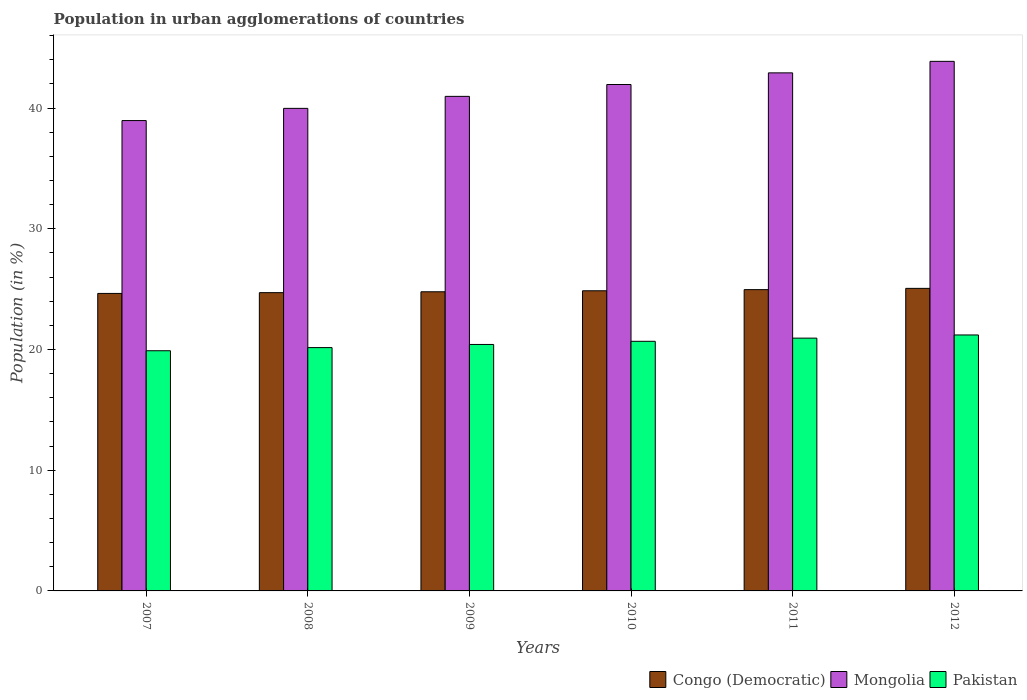How many groups of bars are there?
Give a very brief answer. 6. How many bars are there on the 6th tick from the left?
Your response must be concise. 3. How many bars are there on the 5th tick from the right?
Give a very brief answer. 3. What is the label of the 5th group of bars from the left?
Provide a succinct answer. 2011. What is the percentage of population in urban agglomerations in Mongolia in 2009?
Offer a terse response. 40.96. Across all years, what is the maximum percentage of population in urban agglomerations in Mongolia?
Your response must be concise. 43.86. Across all years, what is the minimum percentage of population in urban agglomerations in Pakistan?
Keep it short and to the point. 19.89. In which year was the percentage of population in urban agglomerations in Mongolia minimum?
Provide a succinct answer. 2007. What is the total percentage of population in urban agglomerations in Pakistan in the graph?
Offer a terse response. 123.28. What is the difference between the percentage of population in urban agglomerations in Congo (Democratic) in 2008 and that in 2009?
Your response must be concise. -0.07. What is the difference between the percentage of population in urban agglomerations in Congo (Democratic) in 2011 and the percentage of population in urban agglomerations in Mongolia in 2010?
Your response must be concise. -16.99. What is the average percentage of population in urban agglomerations in Mongolia per year?
Provide a short and direct response. 41.44. In the year 2009, what is the difference between the percentage of population in urban agglomerations in Mongolia and percentage of population in urban agglomerations in Pakistan?
Ensure brevity in your answer.  20.55. In how many years, is the percentage of population in urban agglomerations in Mongolia greater than 36 %?
Offer a very short reply. 6. What is the ratio of the percentage of population in urban agglomerations in Mongolia in 2008 to that in 2012?
Make the answer very short. 0.91. Is the percentage of population in urban agglomerations in Congo (Democratic) in 2011 less than that in 2012?
Provide a succinct answer. Yes. What is the difference between the highest and the second highest percentage of population in urban agglomerations in Mongolia?
Offer a very short reply. 0.95. What is the difference between the highest and the lowest percentage of population in urban agglomerations in Mongolia?
Provide a succinct answer. 4.91. Is the sum of the percentage of population in urban agglomerations in Congo (Democratic) in 2008 and 2009 greater than the maximum percentage of population in urban agglomerations in Pakistan across all years?
Offer a terse response. Yes. What does the 3rd bar from the left in 2007 represents?
Give a very brief answer. Pakistan. What does the 2nd bar from the right in 2010 represents?
Provide a short and direct response. Mongolia. Are all the bars in the graph horizontal?
Your answer should be very brief. No. How many years are there in the graph?
Provide a short and direct response. 6. What is the difference between two consecutive major ticks on the Y-axis?
Your answer should be very brief. 10. Are the values on the major ticks of Y-axis written in scientific E-notation?
Ensure brevity in your answer.  No. Where does the legend appear in the graph?
Offer a very short reply. Bottom right. How many legend labels are there?
Ensure brevity in your answer.  3. What is the title of the graph?
Provide a short and direct response. Population in urban agglomerations of countries. What is the label or title of the X-axis?
Your answer should be compact. Years. What is the label or title of the Y-axis?
Provide a succinct answer. Population (in %). What is the Population (in %) of Congo (Democratic) in 2007?
Provide a succinct answer. 24.64. What is the Population (in %) in Mongolia in 2007?
Your answer should be very brief. 38.96. What is the Population (in %) of Pakistan in 2007?
Give a very brief answer. 19.89. What is the Population (in %) in Congo (Democratic) in 2008?
Offer a terse response. 24.71. What is the Population (in %) of Mongolia in 2008?
Make the answer very short. 39.97. What is the Population (in %) in Pakistan in 2008?
Give a very brief answer. 20.15. What is the Population (in %) of Congo (Democratic) in 2009?
Provide a short and direct response. 24.78. What is the Population (in %) in Mongolia in 2009?
Your answer should be very brief. 40.96. What is the Population (in %) in Pakistan in 2009?
Your answer should be compact. 20.41. What is the Population (in %) of Congo (Democratic) in 2010?
Offer a terse response. 24.86. What is the Population (in %) of Mongolia in 2010?
Your answer should be very brief. 41.95. What is the Population (in %) of Pakistan in 2010?
Offer a terse response. 20.68. What is the Population (in %) in Congo (Democratic) in 2011?
Your answer should be compact. 24.96. What is the Population (in %) of Mongolia in 2011?
Your answer should be compact. 42.91. What is the Population (in %) in Pakistan in 2011?
Provide a short and direct response. 20.94. What is the Population (in %) of Congo (Democratic) in 2012?
Your answer should be very brief. 25.06. What is the Population (in %) of Mongolia in 2012?
Provide a succinct answer. 43.86. What is the Population (in %) of Pakistan in 2012?
Make the answer very short. 21.2. Across all years, what is the maximum Population (in %) in Congo (Democratic)?
Provide a succinct answer. 25.06. Across all years, what is the maximum Population (in %) in Mongolia?
Your response must be concise. 43.86. Across all years, what is the maximum Population (in %) of Pakistan?
Offer a very short reply. 21.2. Across all years, what is the minimum Population (in %) of Congo (Democratic)?
Provide a short and direct response. 24.64. Across all years, what is the minimum Population (in %) in Mongolia?
Give a very brief answer. 38.96. Across all years, what is the minimum Population (in %) in Pakistan?
Your response must be concise. 19.89. What is the total Population (in %) in Congo (Democratic) in the graph?
Ensure brevity in your answer.  149. What is the total Population (in %) in Mongolia in the graph?
Provide a short and direct response. 248.61. What is the total Population (in %) of Pakistan in the graph?
Give a very brief answer. 123.28. What is the difference between the Population (in %) of Congo (Democratic) in 2007 and that in 2008?
Provide a succinct answer. -0.07. What is the difference between the Population (in %) in Mongolia in 2007 and that in 2008?
Keep it short and to the point. -1.01. What is the difference between the Population (in %) of Pakistan in 2007 and that in 2008?
Provide a short and direct response. -0.26. What is the difference between the Population (in %) of Congo (Democratic) in 2007 and that in 2009?
Ensure brevity in your answer.  -0.14. What is the difference between the Population (in %) in Mongolia in 2007 and that in 2009?
Offer a very short reply. -2.01. What is the difference between the Population (in %) of Pakistan in 2007 and that in 2009?
Offer a terse response. -0.52. What is the difference between the Population (in %) in Congo (Democratic) in 2007 and that in 2010?
Make the answer very short. -0.22. What is the difference between the Population (in %) of Mongolia in 2007 and that in 2010?
Your answer should be compact. -2.99. What is the difference between the Population (in %) of Pakistan in 2007 and that in 2010?
Keep it short and to the point. -0.78. What is the difference between the Population (in %) of Congo (Democratic) in 2007 and that in 2011?
Offer a terse response. -0.31. What is the difference between the Population (in %) in Mongolia in 2007 and that in 2011?
Give a very brief answer. -3.95. What is the difference between the Population (in %) in Pakistan in 2007 and that in 2011?
Keep it short and to the point. -1.04. What is the difference between the Population (in %) in Congo (Democratic) in 2007 and that in 2012?
Make the answer very short. -0.42. What is the difference between the Population (in %) of Mongolia in 2007 and that in 2012?
Ensure brevity in your answer.  -4.91. What is the difference between the Population (in %) of Pakistan in 2007 and that in 2012?
Make the answer very short. -1.31. What is the difference between the Population (in %) in Congo (Democratic) in 2008 and that in 2009?
Ensure brevity in your answer.  -0.07. What is the difference between the Population (in %) in Mongolia in 2008 and that in 2009?
Make the answer very short. -0.99. What is the difference between the Population (in %) of Pakistan in 2008 and that in 2009?
Your response must be concise. -0.26. What is the difference between the Population (in %) of Congo (Democratic) in 2008 and that in 2010?
Your answer should be very brief. -0.16. What is the difference between the Population (in %) in Mongolia in 2008 and that in 2010?
Your response must be concise. -1.98. What is the difference between the Population (in %) of Pakistan in 2008 and that in 2010?
Your answer should be very brief. -0.52. What is the difference between the Population (in %) in Congo (Democratic) in 2008 and that in 2011?
Give a very brief answer. -0.25. What is the difference between the Population (in %) in Mongolia in 2008 and that in 2011?
Your answer should be very brief. -2.94. What is the difference between the Population (in %) of Pakistan in 2008 and that in 2011?
Provide a succinct answer. -0.78. What is the difference between the Population (in %) in Congo (Democratic) in 2008 and that in 2012?
Your response must be concise. -0.35. What is the difference between the Population (in %) in Mongolia in 2008 and that in 2012?
Provide a short and direct response. -3.89. What is the difference between the Population (in %) of Pakistan in 2008 and that in 2012?
Your answer should be very brief. -1.05. What is the difference between the Population (in %) of Congo (Democratic) in 2009 and that in 2010?
Provide a short and direct response. -0.08. What is the difference between the Population (in %) in Mongolia in 2009 and that in 2010?
Offer a very short reply. -0.98. What is the difference between the Population (in %) of Pakistan in 2009 and that in 2010?
Provide a short and direct response. -0.26. What is the difference between the Population (in %) of Congo (Democratic) in 2009 and that in 2011?
Keep it short and to the point. -0.18. What is the difference between the Population (in %) in Mongolia in 2009 and that in 2011?
Provide a succinct answer. -1.95. What is the difference between the Population (in %) in Pakistan in 2009 and that in 2011?
Give a very brief answer. -0.52. What is the difference between the Population (in %) of Congo (Democratic) in 2009 and that in 2012?
Provide a succinct answer. -0.28. What is the difference between the Population (in %) in Mongolia in 2009 and that in 2012?
Provide a short and direct response. -2.9. What is the difference between the Population (in %) of Pakistan in 2009 and that in 2012?
Ensure brevity in your answer.  -0.79. What is the difference between the Population (in %) in Congo (Democratic) in 2010 and that in 2011?
Provide a succinct answer. -0.09. What is the difference between the Population (in %) of Mongolia in 2010 and that in 2011?
Give a very brief answer. -0.96. What is the difference between the Population (in %) in Pakistan in 2010 and that in 2011?
Provide a short and direct response. -0.26. What is the difference between the Population (in %) in Congo (Democratic) in 2010 and that in 2012?
Ensure brevity in your answer.  -0.2. What is the difference between the Population (in %) of Mongolia in 2010 and that in 2012?
Offer a very short reply. -1.92. What is the difference between the Population (in %) in Pakistan in 2010 and that in 2012?
Offer a very short reply. -0.53. What is the difference between the Population (in %) in Congo (Democratic) in 2011 and that in 2012?
Offer a terse response. -0.11. What is the difference between the Population (in %) in Mongolia in 2011 and that in 2012?
Ensure brevity in your answer.  -0.95. What is the difference between the Population (in %) of Pakistan in 2011 and that in 2012?
Your answer should be very brief. -0.26. What is the difference between the Population (in %) in Congo (Democratic) in 2007 and the Population (in %) in Mongolia in 2008?
Keep it short and to the point. -15.33. What is the difference between the Population (in %) of Congo (Democratic) in 2007 and the Population (in %) of Pakistan in 2008?
Your answer should be very brief. 4.49. What is the difference between the Population (in %) in Mongolia in 2007 and the Population (in %) in Pakistan in 2008?
Offer a terse response. 18.8. What is the difference between the Population (in %) in Congo (Democratic) in 2007 and the Population (in %) in Mongolia in 2009?
Keep it short and to the point. -16.32. What is the difference between the Population (in %) in Congo (Democratic) in 2007 and the Population (in %) in Pakistan in 2009?
Your response must be concise. 4.23. What is the difference between the Population (in %) of Mongolia in 2007 and the Population (in %) of Pakistan in 2009?
Keep it short and to the point. 18.54. What is the difference between the Population (in %) of Congo (Democratic) in 2007 and the Population (in %) of Mongolia in 2010?
Ensure brevity in your answer.  -17.3. What is the difference between the Population (in %) of Congo (Democratic) in 2007 and the Population (in %) of Pakistan in 2010?
Offer a terse response. 3.96. What is the difference between the Population (in %) in Mongolia in 2007 and the Population (in %) in Pakistan in 2010?
Provide a short and direct response. 18.28. What is the difference between the Population (in %) of Congo (Democratic) in 2007 and the Population (in %) of Mongolia in 2011?
Ensure brevity in your answer.  -18.27. What is the difference between the Population (in %) of Congo (Democratic) in 2007 and the Population (in %) of Pakistan in 2011?
Provide a succinct answer. 3.7. What is the difference between the Population (in %) of Mongolia in 2007 and the Population (in %) of Pakistan in 2011?
Your answer should be very brief. 18.02. What is the difference between the Population (in %) in Congo (Democratic) in 2007 and the Population (in %) in Mongolia in 2012?
Offer a terse response. -19.22. What is the difference between the Population (in %) of Congo (Democratic) in 2007 and the Population (in %) of Pakistan in 2012?
Your answer should be very brief. 3.44. What is the difference between the Population (in %) in Mongolia in 2007 and the Population (in %) in Pakistan in 2012?
Provide a short and direct response. 17.76. What is the difference between the Population (in %) in Congo (Democratic) in 2008 and the Population (in %) in Mongolia in 2009?
Keep it short and to the point. -16.26. What is the difference between the Population (in %) in Congo (Democratic) in 2008 and the Population (in %) in Pakistan in 2009?
Provide a short and direct response. 4.29. What is the difference between the Population (in %) of Mongolia in 2008 and the Population (in %) of Pakistan in 2009?
Ensure brevity in your answer.  19.55. What is the difference between the Population (in %) in Congo (Democratic) in 2008 and the Population (in %) in Mongolia in 2010?
Give a very brief answer. -17.24. What is the difference between the Population (in %) of Congo (Democratic) in 2008 and the Population (in %) of Pakistan in 2010?
Provide a short and direct response. 4.03. What is the difference between the Population (in %) in Mongolia in 2008 and the Population (in %) in Pakistan in 2010?
Offer a very short reply. 19.29. What is the difference between the Population (in %) in Congo (Democratic) in 2008 and the Population (in %) in Mongolia in 2011?
Provide a short and direct response. -18.2. What is the difference between the Population (in %) of Congo (Democratic) in 2008 and the Population (in %) of Pakistan in 2011?
Ensure brevity in your answer.  3.77. What is the difference between the Population (in %) in Mongolia in 2008 and the Population (in %) in Pakistan in 2011?
Offer a terse response. 19.03. What is the difference between the Population (in %) in Congo (Democratic) in 2008 and the Population (in %) in Mongolia in 2012?
Your answer should be compact. -19.16. What is the difference between the Population (in %) of Congo (Democratic) in 2008 and the Population (in %) of Pakistan in 2012?
Offer a very short reply. 3.5. What is the difference between the Population (in %) of Mongolia in 2008 and the Population (in %) of Pakistan in 2012?
Keep it short and to the point. 18.77. What is the difference between the Population (in %) of Congo (Democratic) in 2009 and the Population (in %) of Mongolia in 2010?
Your answer should be compact. -17.17. What is the difference between the Population (in %) of Congo (Democratic) in 2009 and the Population (in %) of Pakistan in 2010?
Offer a terse response. 4.1. What is the difference between the Population (in %) in Mongolia in 2009 and the Population (in %) in Pakistan in 2010?
Keep it short and to the point. 20.29. What is the difference between the Population (in %) of Congo (Democratic) in 2009 and the Population (in %) of Mongolia in 2011?
Your response must be concise. -18.13. What is the difference between the Population (in %) of Congo (Democratic) in 2009 and the Population (in %) of Pakistan in 2011?
Give a very brief answer. 3.84. What is the difference between the Population (in %) of Mongolia in 2009 and the Population (in %) of Pakistan in 2011?
Offer a very short reply. 20.03. What is the difference between the Population (in %) in Congo (Democratic) in 2009 and the Population (in %) in Mongolia in 2012?
Provide a short and direct response. -19.09. What is the difference between the Population (in %) in Congo (Democratic) in 2009 and the Population (in %) in Pakistan in 2012?
Provide a short and direct response. 3.58. What is the difference between the Population (in %) in Mongolia in 2009 and the Population (in %) in Pakistan in 2012?
Provide a short and direct response. 19.76. What is the difference between the Population (in %) in Congo (Democratic) in 2010 and the Population (in %) in Mongolia in 2011?
Offer a very short reply. -18.05. What is the difference between the Population (in %) in Congo (Democratic) in 2010 and the Population (in %) in Pakistan in 2011?
Your answer should be very brief. 3.92. What is the difference between the Population (in %) in Mongolia in 2010 and the Population (in %) in Pakistan in 2011?
Your response must be concise. 21.01. What is the difference between the Population (in %) of Congo (Democratic) in 2010 and the Population (in %) of Mongolia in 2012?
Your answer should be compact. -19. What is the difference between the Population (in %) of Congo (Democratic) in 2010 and the Population (in %) of Pakistan in 2012?
Your response must be concise. 3.66. What is the difference between the Population (in %) in Mongolia in 2010 and the Population (in %) in Pakistan in 2012?
Provide a succinct answer. 20.74. What is the difference between the Population (in %) of Congo (Democratic) in 2011 and the Population (in %) of Mongolia in 2012?
Your answer should be compact. -18.91. What is the difference between the Population (in %) in Congo (Democratic) in 2011 and the Population (in %) in Pakistan in 2012?
Provide a short and direct response. 3.75. What is the difference between the Population (in %) in Mongolia in 2011 and the Population (in %) in Pakistan in 2012?
Make the answer very short. 21.71. What is the average Population (in %) of Congo (Democratic) per year?
Make the answer very short. 24.83. What is the average Population (in %) of Mongolia per year?
Give a very brief answer. 41.44. What is the average Population (in %) of Pakistan per year?
Offer a very short reply. 20.55. In the year 2007, what is the difference between the Population (in %) in Congo (Democratic) and Population (in %) in Mongolia?
Provide a succinct answer. -14.32. In the year 2007, what is the difference between the Population (in %) in Congo (Democratic) and Population (in %) in Pakistan?
Offer a very short reply. 4.75. In the year 2007, what is the difference between the Population (in %) in Mongolia and Population (in %) in Pakistan?
Provide a succinct answer. 19.06. In the year 2008, what is the difference between the Population (in %) of Congo (Democratic) and Population (in %) of Mongolia?
Provide a succinct answer. -15.26. In the year 2008, what is the difference between the Population (in %) of Congo (Democratic) and Population (in %) of Pakistan?
Make the answer very short. 4.55. In the year 2008, what is the difference between the Population (in %) in Mongolia and Population (in %) in Pakistan?
Give a very brief answer. 19.82. In the year 2009, what is the difference between the Population (in %) in Congo (Democratic) and Population (in %) in Mongolia?
Your answer should be very brief. -16.19. In the year 2009, what is the difference between the Population (in %) of Congo (Democratic) and Population (in %) of Pakistan?
Make the answer very short. 4.36. In the year 2009, what is the difference between the Population (in %) in Mongolia and Population (in %) in Pakistan?
Make the answer very short. 20.55. In the year 2010, what is the difference between the Population (in %) in Congo (Democratic) and Population (in %) in Mongolia?
Provide a short and direct response. -17.08. In the year 2010, what is the difference between the Population (in %) in Congo (Democratic) and Population (in %) in Pakistan?
Provide a short and direct response. 4.19. In the year 2010, what is the difference between the Population (in %) in Mongolia and Population (in %) in Pakistan?
Provide a short and direct response. 21.27. In the year 2011, what is the difference between the Population (in %) in Congo (Democratic) and Population (in %) in Mongolia?
Provide a short and direct response. -17.95. In the year 2011, what is the difference between the Population (in %) in Congo (Democratic) and Population (in %) in Pakistan?
Give a very brief answer. 4.02. In the year 2011, what is the difference between the Population (in %) of Mongolia and Population (in %) of Pakistan?
Offer a terse response. 21.97. In the year 2012, what is the difference between the Population (in %) in Congo (Democratic) and Population (in %) in Mongolia?
Ensure brevity in your answer.  -18.8. In the year 2012, what is the difference between the Population (in %) of Congo (Democratic) and Population (in %) of Pakistan?
Offer a terse response. 3.86. In the year 2012, what is the difference between the Population (in %) in Mongolia and Population (in %) in Pakistan?
Ensure brevity in your answer.  22.66. What is the ratio of the Population (in %) in Congo (Democratic) in 2007 to that in 2008?
Keep it short and to the point. 1. What is the ratio of the Population (in %) in Mongolia in 2007 to that in 2008?
Provide a succinct answer. 0.97. What is the ratio of the Population (in %) in Pakistan in 2007 to that in 2008?
Ensure brevity in your answer.  0.99. What is the ratio of the Population (in %) in Mongolia in 2007 to that in 2009?
Your answer should be very brief. 0.95. What is the ratio of the Population (in %) in Pakistan in 2007 to that in 2009?
Provide a succinct answer. 0.97. What is the ratio of the Population (in %) in Congo (Democratic) in 2007 to that in 2010?
Your answer should be compact. 0.99. What is the ratio of the Population (in %) in Mongolia in 2007 to that in 2010?
Offer a very short reply. 0.93. What is the ratio of the Population (in %) of Pakistan in 2007 to that in 2010?
Give a very brief answer. 0.96. What is the ratio of the Population (in %) in Congo (Democratic) in 2007 to that in 2011?
Make the answer very short. 0.99. What is the ratio of the Population (in %) of Mongolia in 2007 to that in 2011?
Provide a short and direct response. 0.91. What is the ratio of the Population (in %) in Pakistan in 2007 to that in 2011?
Provide a succinct answer. 0.95. What is the ratio of the Population (in %) of Congo (Democratic) in 2007 to that in 2012?
Keep it short and to the point. 0.98. What is the ratio of the Population (in %) in Mongolia in 2007 to that in 2012?
Provide a succinct answer. 0.89. What is the ratio of the Population (in %) in Pakistan in 2007 to that in 2012?
Your response must be concise. 0.94. What is the ratio of the Population (in %) in Mongolia in 2008 to that in 2009?
Make the answer very short. 0.98. What is the ratio of the Population (in %) of Pakistan in 2008 to that in 2009?
Give a very brief answer. 0.99. What is the ratio of the Population (in %) of Mongolia in 2008 to that in 2010?
Provide a succinct answer. 0.95. What is the ratio of the Population (in %) of Pakistan in 2008 to that in 2010?
Your answer should be compact. 0.97. What is the ratio of the Population (in %) in Congo (Democratic) in 2008 to that in 2011?
Provide a succinct answer. 0.99. What is the ratio of the Population (in %) in Mongolia in 2008 to that in 2011?
Your answer should be very brief. 0.93. What is the ratio of the Population (in %) in Pakistan in 2008 to that in 2011?
Offer a terse response. 0.96. What is the ratio of the Population (in %) of Congo (Democratic) in 2008 to that in 2012?
Offer a very short reply. 0.99. What is the ratio of the Population (in %) of Mongolia in 2008 to that in 2012?
Provide a succinct answer. 0.91. What is the ratio of the Population (in %) in Pakistan in 2008 to that in 2012?
Make the answer very short. 0.95. What is the ratio of the Population (in %) in Congo (Democratic) in 2009 to that in 2010?
Make the answer very short. 1. What is the ratio of the Population (in %) in Mongolia in 2009 to that in 2010?
Your response must be concise. 0.98. What is the ratio of the Population (in %) in Pakistan in 2009 to that in 2010?
Offer a very short reply. 0.99. What is the ratio of the Population (in %) of Mongolia in 2009 to that in 2011?
Provide a short and direct response. 0.95. What is the ratio of the Population (in %) of Pakistan in 2009 to that in 2011?
Provide a short and direct response. 0.97. What is the ratio of the Population (in %) of Congo (Democratic) in 2009 to that in 2012?
Provide a succinct answer. 0.99. What is the ratio of the Population (in %) of Mongolia in 2009 to that in 2012?
Your answer should be very brief. 0.93. What is the ratio of the Population (in %) in Pakistan in 2009 to that in 2012?
Ensure brevity in your answer.  0.96. What is the ratio of the Population (in %) in Congo (Democratic) in 2010 to that in 2011?
Give a very brief answer. 1. What is the ratio of the Population (in %) in Mongolia in 2010 to that in 2011?
Offer a terse response. 0.98. What is the ratio of the Population (in %) in Pakistan in 2010 to that in 2011?
Provide a short and direct response. 0.99. What is the ratio of the Population (in %) in Congo (Democratic) in 2010 to that in 2012?
Your response must be concise. 0.99. What is the ratio of the Population (in %) of Mongolia in 2010 to that in 2012?
Give a very brief answer. 0.96. What is the ratio of the Population (in %) of Pakistan in 2010 to that in 2012?
Provide a short and direct response. 0.98. What is the ratio of the Population (in %) of Mongolia in 2011 to that in 2012?
Your answer should be very brief. 0.98. What is the ratio of the Population (in %) in Pakistan in 2011 to that in 2012?
Offer a terse response. 0.99. What is the difference between the highest and the second highest Population (in %) of Congo (Democratic)?
Ensure brevity in your answer.  0.11. What is the difference between the highest and the second highest Population (in %) of Mongolia?
Keep it short and to the point. 0.95. What is the difference between the highest and the second highest Population (in %) in Pakistan?
Your response must be concise. 0.26. What is the difference between the highest and the lowest Population (in %) in Congo (Democratic)?
Offer a terse response. 0.42. What is the difference between the highest and the lowest Population (in %) in Mongolia?
Ensure brevity in your answer.  4.91. What is the difference between the highest and the lowest Population (in %) in Pakistan?
Provide a short and direct response. 1.31. 